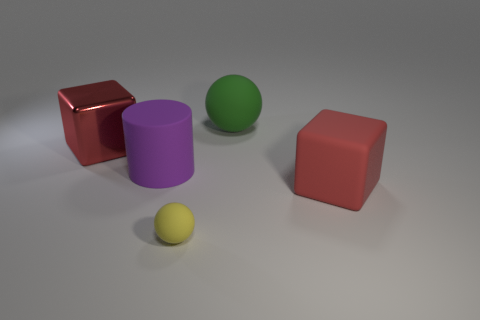Add 2 large red rubber things. How many objects exist? 7 Subtract 1 cubes. How many cubes are left? 1 Subtract 2 red cubes. How many objects are left? 3 Subtract all balls. How many objects are left? 3 Subtract all red balls. Subtract all purple cubes. How many balls are left? 2 Subtract all gray blocks. How many green spheres are left? 1 Subtract all small red cylinders. Subtract all large purple matte cylinders. How many objects are left? 4 Add 4 big red things. How many big red things are left? 6 Add 1 big blue balls. How many big blue balls exist? 1 